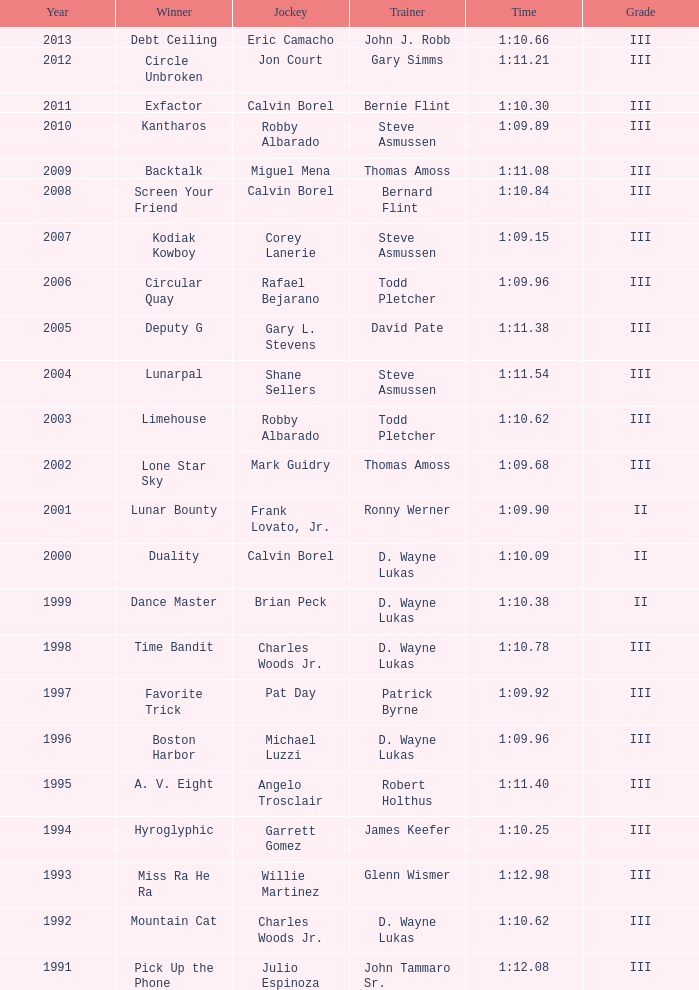Which instructor emerged victorious in the hyroglyphic in a year preceding 2010? James Keefer. 